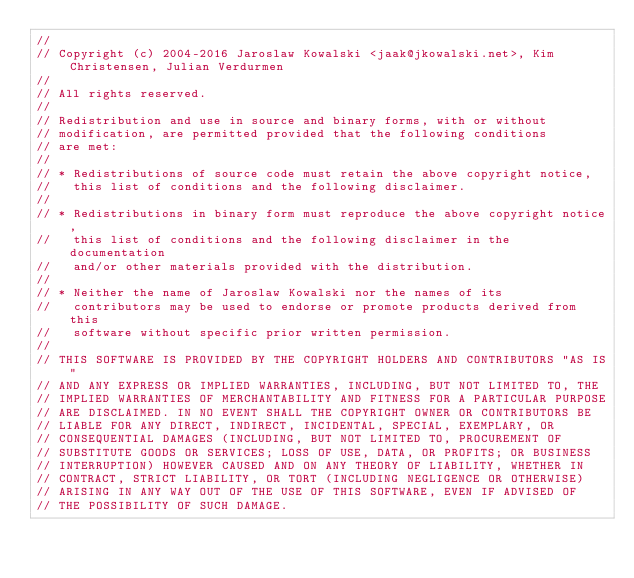<code> <loc_0><loc_0><loc_500><loc_500><_C#_>// 
// Copyright (c) 2004-2016 Jaroslaw Kowalski <jaak@jkowalski.net>, Kim Christensen, Julian Verdurmen
// 
// All rights reserved.
// 
// Redistribution and use in source and binary forms, with or without 
// modification, are permitted provided that the following conditions 
// are met:
// 
// * Redistributions of source code must retain the above copyright notice, 
//   this list of conditions and the following disclaimer. 
// 
// * Redistributions in binary form must reproduce the above copyright notice,
//   this list of conditions and the following disclaimer in the documentation
//   and/or other materials provided with the distribution. 
// 
// * Neither the name of Jaroslaw Kowalski nor the names of its 
//   contributors may be used to endorse or promote products derived from this
//   software without specific prior written permission. 
// 
// THIS SOFTWARE IS PROVIDED BY THE COPYRIGHT HOLDERS AND CONTRIBUTORS "AS IS"
// AND ANY EXPRESS OR IMPLIED WARRANTIES, INCLUDING, BUT NOT LIMITED TO, THE 
// IMPLIED WARRANTIES OF MERCHANTABILITY AND FITNESS FOR A PARTICULAR PURPOSE 
// ARE DISCLAIMED. IN NO EVENT SHALL THE COPYRIGHT OWNER OR CONTRIBUTORS BE 
// LIABLE FOR ANY DIRECT, INDIRECT, INCIDENTAL, SPECIAL, EXEMPLARY, OR 
// CONSEQUENTIAL DAMAGES (INCLUDING, BUT NOT LIMITED TO, PROCUREMENT OF
// SUBSTITUTE GOODS OR SERVICES; LOSS OF USE, DATA, OR PROFITS; OR BUSINESS 
// INTERRUPTION) HOWEVER CAUSED AND ON ANY THEORY OF LIABILITY, WHETHER IN 
// CONTRACT, STRICT LIABILITY, OR TORT (INCLUDING NEGLIGENCE OR OTHERWISE) 
// ARISING IN ANY WAY OUT OF THE USE OF THIS SOFTWARE, EVEN IF ADVISED OF 
// THE POSSIBILITY OF SUCH DAMAGE.</code> 